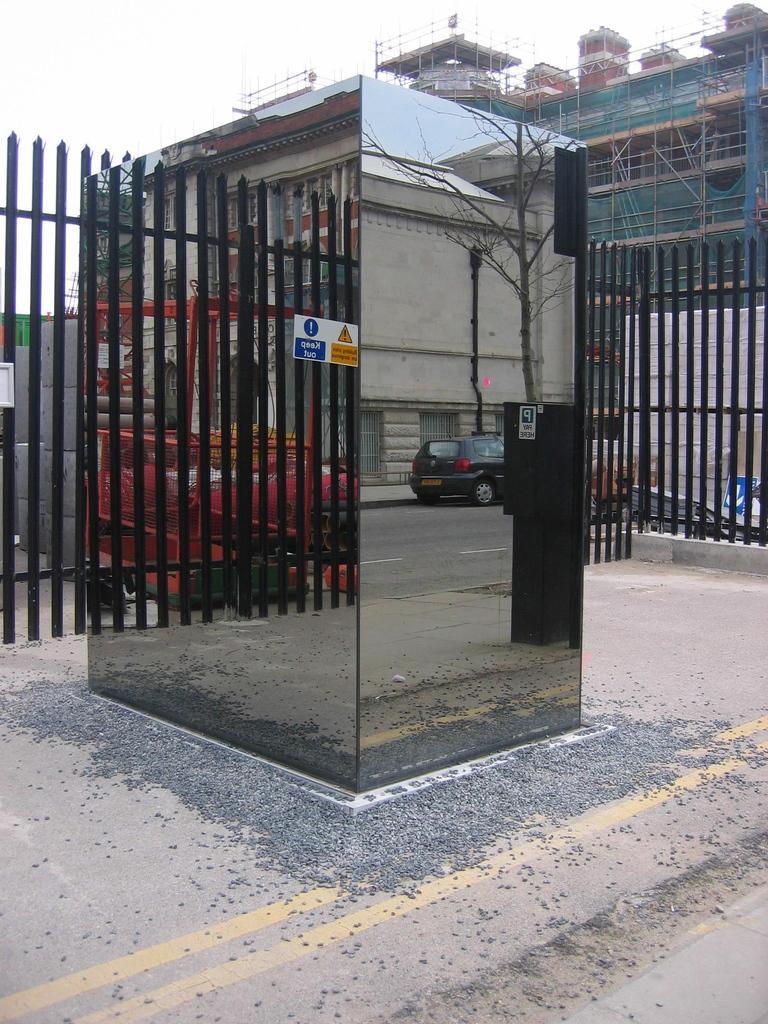How would you summarize this image in a sentence or two? In this picture we can see glasses in the front, we can see reflections of a car and a tree on this glass, on the left side there is a fencing panel, in the background we can see a building, we can also see some sticks, there is the sky at the top of the picture. 